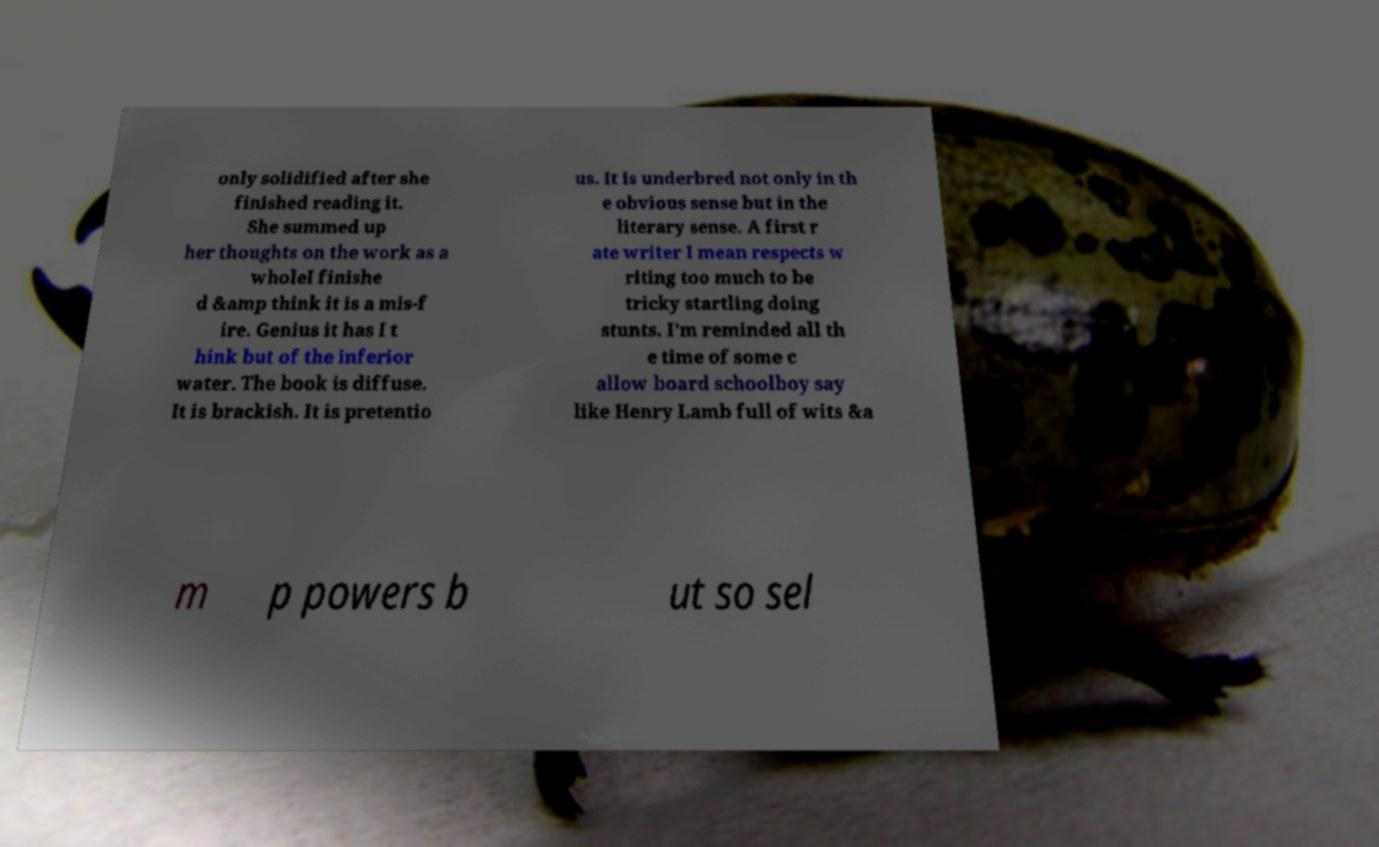Could you assist in decoding the text presented in this image and type it out clearly? only solidified after she finished reading it. She summed up her thoughts on the work as a wholeI finishe d &amp think it is a mis-f ire. Genius it has I t hink but of the inferior water. The book is diffuse. It is brackish. It is pretentio us. It is underbred not only in th e obvious sense but in the literary sense. A first r ate writer I mean respects w riting too much to be tricky startling doing stunts. I’m reminded all th e time of some c allow board schoolboy say like Henry Lamb full of wits &a m p powers b ut so sel 